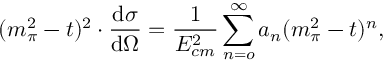<formula> <loc_0><loc_0><loc_500><loc_500>( m _ { \pi } ^ { 2 } - t ) ^ { 2 } \cdot \frac { d \sigma } { d \Omega } = \frac { 1 } { E _ { c m } ^ { 2 } } \sum _ { n = o } ^ { \infty } a _ { n } ( m _ { \pi } ^ { 2 } - t ) ^ { n } ,</formula> 